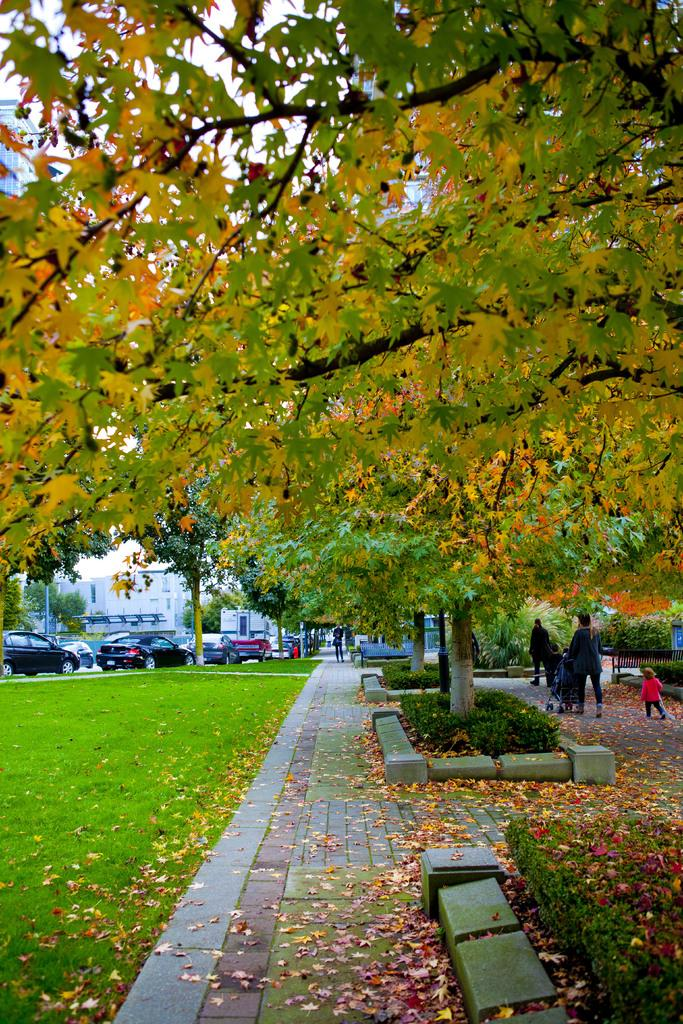What type of vegetation can be seen in the image? There are trees in the image. What other natural elements are present in the image? There are stones and grass in the image. What man-made structures can be seen in the image? There are buildings in the image. What mode of transportation is visible in the image? There are cars in the image. What activity are people engaged in within the image? There are people walking on the road in the image. In which direction is the wilderness located in the image? There is no wilderness present in the image; it features a mix of natural and man-made elements. How are the cars sorted in the image? The cars are not sorted in any particular way in the image; they are simply parked or driving on the road. 